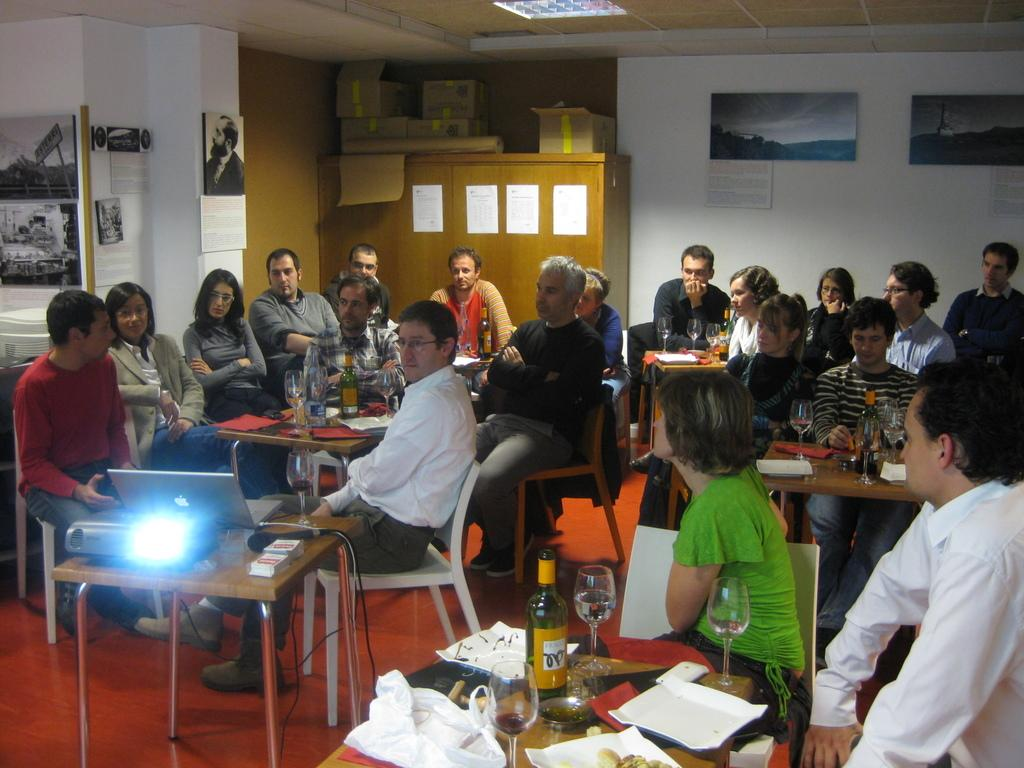How many people are in the image? There is a group of people in the image. What are the people doing in the image? The people are sitting on a chair and looking at a laptop. What is on the table in the image? There is a wooden table in the image with a projector, a laptop, and a microphone on it. Reasoning: Let's thinking step by step to create the conversation. First, he identifies the main subject, which is the group of people. Then, he describes what they are doing and where they are located. Next, he focuses on the objects in the image, specifically the wooden table and its contents. Each question is designed to elicit a specific detail about the image that is known from the provided facts. Absurd Question/Answer: What type of friction can be seen between the ducks in the image? There are no ducks present in the image, so there is no friction to observe. 